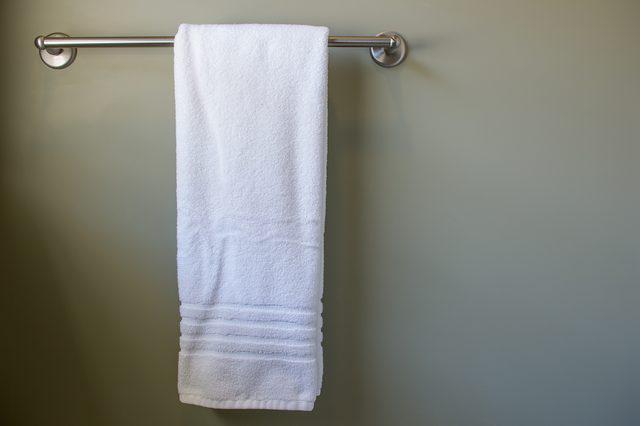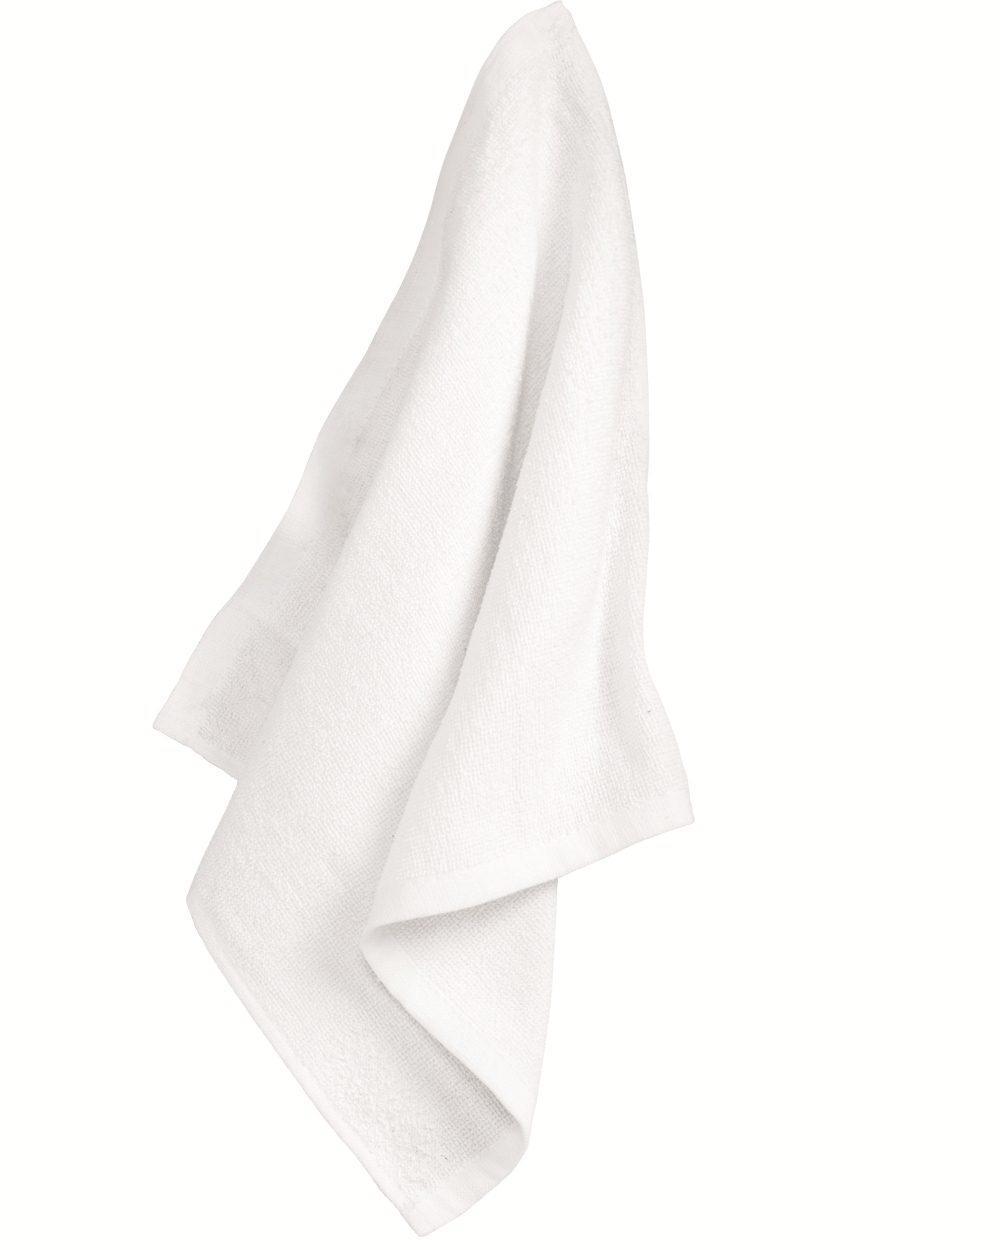The first image is the image on the left, the second image is the image on the right. Evaluate the accuracy of this statement regarding the images: "In one of the images there is a single white towel hanging on a towel bar.". Is it true? Answer yes or no. Yes. 